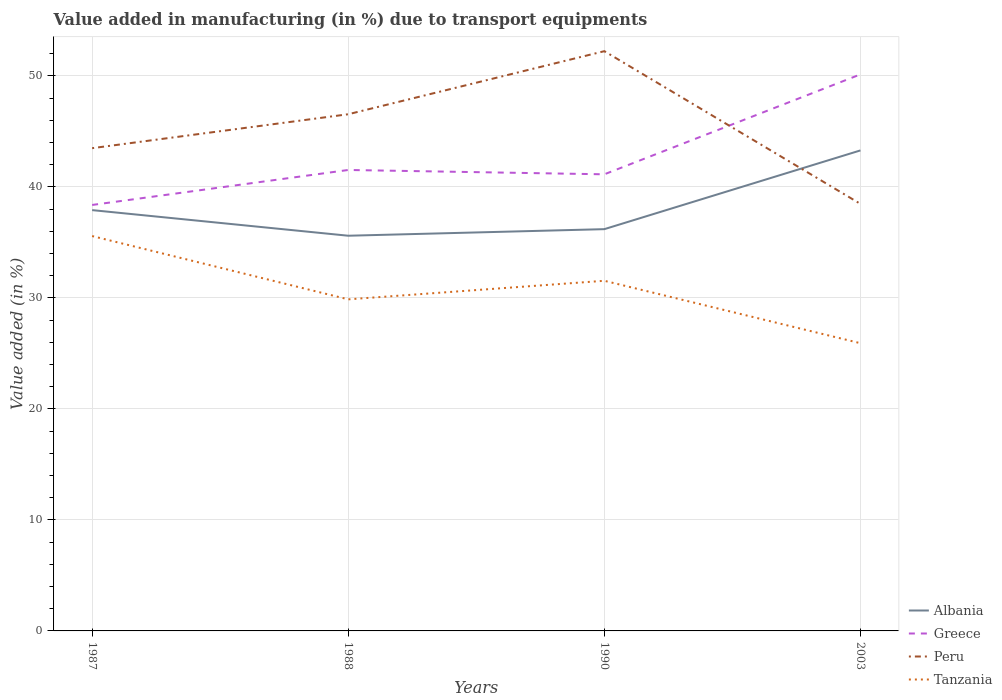Does the line corresponding to Greece intersect with the line corresponding to Albania?
Your answer should be compact. No. Across all years, what is the maximum percentage of value added in manufacturing due to transport equipments in Greece?
Ensure brevity in your answer.  38.37. What is the total percentage of value added in manufacturing due to transport equipments in Greece in the graph?
Give a very brief answer. -9. What is the difference between the highest and the second highest percentage of value added in manufacturing due to transport equipments in Peru?
Offer a terse response. 13.76. How many years are there in the graph?
Your answer should be very brief. 4. How many legend labels are there?
Keep it short and to the point. 4. What is the title of the graph?
Offer a very short reply. Value added in manufacturing (in %) due to transport equipments. Does "Afghanistan" appear as one of the legend labels in the graph?
Make the answer very short. No. What is the label or title of the X-axis?
Your answer should be compact. Years. What is the label or title of the Y-axis?
Your response must be concise. Value added (in %). What is the Value added (in %) of Albania in 1987?
Your response must be concise. 37.91. What is the Value added (in %) of Greece in 1987?
Provide a succinct answer. 38.37. What is the Value added (in %) of Peru in 1987?
Provide a succinct answer. 43.49. What is the Value added (in %) of Tanzania in 1987?
Make the answer very short. 35.57. What is the Value added (in %) in Albania in 1988?
Provide a short and direct response. 35.6. What is the Value added (in %) of Greece in 1988?
Your response must be concise. 41.52. What is the Value added (in %) in Peru in 1988?
Offer a terse response. 46.55. What is the Value added (in %) in Tanzania in 1988?
Your answer should be very brief. 29.87. What is the Value added (in %) in Albania in 1990?
Offer a terse response. 36.19. What is the Value added (in %) of Greece in 1990?
Ensure brevity in your answer.  41.13. What is the Value added (in %) in Peru in 1990?
Provide a succinct answer. 52.23. What is the Value added (in %) in Tanzania in 1990?
Offer a terse response. 31.54. What is the Value added (in %) of Albania in 2003?
Your response must be concise. 43.29. What is the Value added (in %) in Greece in 2003?
Make the answer very short. 50.14. What is the Value added (in %) in Peru in 2003?
Provide a short and direct response. 38.47. What is the Value added (in %) of Tanzania in 2003?
Keep it short and to the point. 25.92. Across all years, what is the maximum Value added (in %) in Albania?
Your answer should be very brief. 43.29. Across all years, what is the maximum Value added (in %) in Greece?
Provide a short and direct response. 50.14. Across all years, what is the maximum Value added (in %) of Peru?
Provide a short and direct response. 52.23. Across all years, what is the maximum Value added (in %) in Tanzania?
Ensure brevity in your answer.  35.57. Across all years, what is the minimum Value added (in %) in Albania?
Offer a terse response. 35.6. Across all years, what is the minimum Value added (in %) in Greece?
Provide a succinct answer. 38.37. Across all years, what is the minimum Value added (in %) of Peru?
Make the answer very short. 38.47. Across all years, what is the minimum Value added (in %) in Tanzania?
Offer a very short reply. 25.92. What is the total Value added (in %) in Albania in the graph?
Give a very brief answer. 152.99. What is the total Value added (in %) in Greece in the graph?
Keep it short and to the point. 171.17. What is the total Value added (in %) in Peru in the graph?
Give a very brief answer. 180.73. What is the total Value added (in %) of Tanzania in the graph?
Keep it short and to the point. 122.9. What is the difference between the Value added (in %) of Albania in 1987 and that in 1988?
Provide a short and direct response. 2.31. What is the difference between the Value added (in %) of Greece in 1987 and that in 1988?
Provide a short and direct response. -3.15. What is the difference between the Value added (in %) in Peru in 1987 and that in 1988?
Your answer should be very brief. -3.06. What is the difference between the Value added (in %) in Tanzania in 1987 and that in 1988?
Provide a short and direct response. 5.7. What is the difference between the Value added (in %) of Albania in 1987 and that in 1990?
Ensure brevity in your answer.  1.71. What is the difference between the Value added (in %) in Greece in 1987 and that in 1990?
Offer a terse response. -2.76. What is the difference between the Value added (in %) of Peru in 1987 and that in 1990?
Provide a succinct answer. -8.74. What is the difference between the Value added (in %) in Tanzania in 1987 and that in 1990?
Provide a succinct answer. 4.03. What is the difference between the Value added (in %) of Albania in 1987 and that in 2003?
Your answer should be very brief. -5.38. What is the difference between the Value added (in %) of Greece in 1987 and that in 2003?
Provide a short and direct response. -11.76. What is the difference between the Value added (in %) in Peru in 1987 and that in 2003?
Give a very brief answer. 5.02. What is the difference between the Value added (in %) of Tanzania in 1987 and that in 2003?
Make the answer very short. 9.65. What is the difference between the Value added (in %) in Albania in 1988 and that in 1990?
Your answer should be compact. -0.59. What is the difference between the Value added (in %) in Greece in 1988 and that in 1990?
Keep it short and to the point. 0.39. What is the difference between the Value added (in %) of Peru in 1988 and that in 1990?
Offer a very short reply. -5.68. What is the difference between the Value added (in %) of Tanzania in 1988 and that in 1990?
Offer a terse response. -1.67. What is the difference between the Value added (in %) in Albania in 1988 and that in 2003?
Offer a terse response. -7.69. What is the difference between the Value added (in %) in Greece in 1988 and that in 2003?
Offer a very short reply. -8.61. What is the difference between the Value added (in %) of Peru in 1988 and that in 2003?
Offer a terse response. 8.08. What is the difference between the Value added (in %) in Tanzania in 1988 and that in 2003?
Provide a succinct answer. 3.95. What is the difference between the Value added (in %) in Albania in 1990 and that in 2003?
Provide a succinct answer. -7.09. What is the difference between the Value added (in %) of Greece in 1990 and that in 2003?
Offer a terse response. -9. What is the difference between the Value added (in %) of Peru in 1990 and that in 2003?
Your response must be concise. 13.76. What is the difference between the Value added (in %) of Tanzania in 1990 and that in 2003?
Offer a very short reply. 5.62. What is the difference between the Value added (in %) of Albania in 1987 and the Value added (in %) of Greece in 1988?
Your answer should be very brief. -3.62. What is the difference between the Value added (in %) of Albania in 1987 and the Value added (in %) of Peru in 1988?
Offer a terse response. -8.64. What is the difference between the Value added (in %) of Albania in 1987 and the Value added (in %) of Tanzania in 1988?
Your answer should be compact. 8.04. What is the difference between the Value added (in %) in Greece in 1987 and the Value added (in %) in Peru in 1988?
Ensure brevity in your answer.  -8.17. What is the difference between the Value added (in %) in Greece in 1987 and the Value added (in %) in Tanzania in 1988?
Keep it short and to the point. 8.5. What is the difference between the Value added (in %) in Peru in 1987 and the Value added (in %) in Tanzania in 1988?
Ensure brevity in your answer.  13.62. What is the difference between the Value added (in %) of Albania in 1987 and the Value added (in %) of Greece in 1990?
Give a very brief answer. -3.23. What is the difference between the Value added (in %) of Albania in 1987 and the Value added (in %) of Peru in 1990?
Provide a succinct answer. -14.32. What is the difference between the Value added (in %) in Albania in 1987 and the Value added (in %) in Tanzania in 1990?
Your answer should be compact. 6.37. What is the difference between the Value added (in %) of Greece in 1987 and the Value added (in %) of Peru in 1990?
Provide a succinct answer. -13.85. What is the difference between the Value added (in %) of Greece in 1987 and the Value added (in %) of Tanzania in 1990?
Offer a very short reply. 6.83. What is the difference between the Value added (in %) in Peru in 1987 and the Value added (in %) in Tanzania in 1990?
Make the answer very short. 11.95. What is the difference between the Value added (in %) of Albania in 1987 and the Value added (in %) of Greece in 2003?
Keep it short and to the point. -12.23. What is the difference between the Value added (in %) of Albania in 1987 and the Value added (in %) of Peru in 2003?
Make the answer very short. -0.56. What is the difference between the Value added (in %) of Albania in 1987 and the Value added (in %) of Tanzania in 2003?
Offer a terse response. 11.99. What is the difference between the Value added (in %) in Greece in 1987 and the Value added (in %) in Peru in 2003?
Make the answer very short. -0.1. What is the difference between the Value added (in %) in Greece in 1987 and the Value added (in %) in Tanzania in 2003?
Your answer should be compact. 12.46. What is the difference between the Value added (in %) in Peru in 1987 and the Value added (in %) in Tanzania in 2003?
Provide a short and direct response. 17.57. What is the difference between the Value added (in %) in Albania in 1988 and the Value added (in %) in Greece in 1990?
Offer a very short reply. -5.53. What is the difference between the Value added (in %) in Albania in 1988 and the Value added (in %) in Peru in 1990?
Your answer should be very brief. -16.63. What is the difference between the Value added (in %) in Albania in 1988 and the Value added (in %) in Tanzania in 1990?
Keep it short and to the point. 4.06. What is the difference between the Value added (in %) in Greece in 1988 and the Value added (in %) in Peru in 1990?
Provide a succinct answer. -10.7. What is the difference between the Value added (in %) in Greece in 1988 and the Value added (in %) in Tanzania in 1990?
Keep it short and to the point. 9.98. What is the difference between the Value added (in %) in Peru in 1988 and the Value added (in %) in Tanzania in 1990?
Make the answer very short. 15. What is the difference between the Value added (in %) in Albania in 1988 and the Value added (in %) in Greece in 2003?
Your answer should be compact. -14.54. What is the difference between the Value added (in %) in Albania in 1988 and the Value added (in %) in Peru in 2003?
Keep it short and to the point. -2.87. What is the difference between the Value added (in %) in Albania in 1988 and the Value added (in %) in Tanzania in 2003?
Give a very brief answer. 9.68. What is the difference between the Value added (in %) of Greece in 1988 and the Value added (in %) of Peru in 2003?
Your answer should be compact. 3.06. What is the difference between the Value added (in %) of Greece in 1988 and the Value added (in %) of Tanzania in 2003?
Offer a very short reply. 15.61. What is the difference between the Value added (in %) of Peru in 1988 and the Value added (in %) of Tanzania in 2003?
Your answer should be very brief. 20.63. What is the difference between the Value added (in %) in Albania in 1990 and the Value added (in %) in Greece in 2003?
Offer a very short reply. -13.94. What is the difference between the Value added (in %) in Albania in 1990 and the Value added (in %) in Peru in 2003?
Keep it short and to the point. -2.27. What is the difference between the Value added (in %) of Albania in 1990 and the Value added (in %) of Tanzania in 2003?
Provide a succinct answer. 10.28. What is the difference between the Value added (in %) in Greece in 1990 and the Value added (in %) in Peru in 2003?
Keep it short and to the point. 2.67. What is the difference between the Value added (in %) in Greece in 1990 and the Value added (in %) in Tanzania in 2003?
Your answer should be compact. 15.22. What is the difference between the Value added (in %) in Peru in 1990 and the Value added (in %) in Tanzania in 2003?
Your answer should be very brief. 26.31. What is the average Value added (in %) in Albania per year?
Keep it short and to the point. 38.25. What is the average Value added (in %) of Greece per year?
Make the answer very short. 42.79. What is the average Value added (in %) in Peru per year?
Provide a short and direct response. 45.18. What is the average Value added (in %) of Tanzania per year?
Ensure brevity in your answer.  30.73. In the year 1987, what is the difference between the Value added (in %) in Albania and Value added (in %) in Greece?
Offer a very short reply. -0.46. In the year 1987, what is the difference between the Value added (in %) of Albania and Value added (in %) of Peru?
Ensure brevity in your answer.  -5.58. In the year 1987, what is the difference between the Value added (in %) of Albania and Value added (in %) of Tanzania?
Your response must be concise. 2.34. In the year 1987, what is the difference between the Value added (in %) in Greece and Value added (in %) in Peru?
Provide a short and direct response. -5.11. In the year 1987, what is the difference between the Value added (in %) of Greece and Value added (in %) of Tanzania?
Provide a succinct answer. 2.8. In the year 1987, what is the difference between the Value added (in %) of Peru and Value added (in %) of Tanzania?
Provide a short and direct response. 7.92. In the year 1988, what is the difference between the Value added (in %) in Albania and Value added (in %) in Greece?
Offer a very short reply. -5.92. In the year 1988, what is the difference between the Value added (in %) in Albania and Value added (in %) in Peru?
Keep it short and to the point. -10.94. In the year 1988, what is the difference between the Value added (in %) of Albania and Value added (in %) of Tanzania?
Make the answer very short. 5.73. In the year 1988, what is the difference between the Value added (in %) of Greece and Value added (in %) of Peru?
Provide a short and direct response. -5.02. In the year 1988, what is the difference between the Value added (in %) of Greece and Value added (in %) of Tanzania?
Provide a succinct answer. 11.65. In the year 1988, what is the difference between the Value added (in %) of Peru and Value added (in %) of Tanzania?
Offer a very short reply. 16.68. In the year 1990, what is the difference between the Value added (in %) in Albania and Value added (in %) in Greece?
Your answer should be compact. -4.94. In the year 1990, what is the difference between the Value added (in %) in Albania and Value added (in %) in Peru?
Provide a short and direct response. -16.03. In the year 1990, what is the difference between the Value added (in %) of Albania and Value added (in %) of Tanzania?
Keep it short and to the point. 4.65. In the year 1990, what is the difference between the Value added (in %) of Greece and Value added (in %) of Peru?
Provide a succinct answer. -11.09. In the year 1990, what is the difference between the Value added (in %) in Greece and Value added (in %) in Tanzania?
Your answer should be very brief. 9.59. In the year 1990, what is the difference between the Value added (in %) of Peru and Value added (in %) of Tanzania?
Your response must be concise. 20.68. In the year 2003, what is the difference between the Value added (in %) in Albania and Value added (in %) in Greece?
Offer a very short reply. -6.85. In the year 2003, what is the difference between the Value added (in %) in Albania and Value added (in %) in Peru?
Provide a short and direct response. 4.82. In the year 2003, what is the difference between the Value added (in %) in Albania and Value added (in %) in Tanzania?
Give a very brief answer. 17.37. In the year 2003, what is the difference between the Value added (in %) in Greece and Value added (in %) in Peru?
Make the answer very short. 11.67. In the year 2003, what is the difference between the Value added (in %) in Greece and Value added (in %) in Tanzania?
Offer a terse response. 24.22. In the year 2003, what is the difference between the Value added (in %) in Peru and Value added (in %) in Tanzania?
Your response must be concise. 12.55. What is the ratio of the Value added (in %) of Albania in 1987 to that in 1988?
Provide a short and direct response. 1.06. What is the ratio of the Value added (in %) in Greece in 1987 to that in 1988?
Your response must be concise. 0.92. What is the ratio of the Value added (in %) of Peru in 1987 to that in 1988?
Your answer should be very brief. 0.93. What is the ratio of the Value added (in %) in Tanzania in 1987 to that in 1988?
Offer a terse response. 1.19. What is the ratio of the Value added (in %) in Albania in 1987 to that in 1990?
Your answer should be compact. 1.05. What is the ratio of the Value added (in %) in Greece in 1987 to that in 1990?
Provide a short and direct response. 0.93. What is the ratio of the Value added (in %) in Peru in 1987 to that in 1990?
Offer a terse response. 0.83. What is the ratio of the Value added (in %) in Tanzania in 1987 to that in 1990?
Ensure brevity in your answer.  1.13. What is the ratio of the Value added (in %) of Albania in 1987 to that in 2003?
Ensure brevity in your answer.  0.88. What is the ratio of the Value added (in %) in Greece in 1987 to that in 2003?
Keep it short and to the point. 0.77. What is the ratio of the Value added (in %) in Peru in 1987 to that in 2003?
Offer a terse response. 1.13. What is the ratio of the Value added (in %) in Tanzania in 1987 to that in 2003?
Offer a very short reply. 1.37. What is the ratio of the Value added (in %) in Albania in 1988 to that in 1990?
Provide a succinct answer. 0.98. What is the ratio of the Value added (in %) in Greece in 1988 to that in 1990?
Your response must be concise. 1.01. What is the ratio of the Value added (in %) of Peru in 1988 to that in 1990?
Provide a short and direct response. 0.89. What is the ratio of the Value added (in %) of Tanzania in 1988 to that in 1990?
Offer a very short reply. 0.95. What is the ratio of the Value added (in %) in Albania in 1988 to that in 2003?
Offer a terse response. 0.82. What is the ratio of the Value added (in %) of Greece in 1988 to that in 2003?
Provide a short and direct response. 0.83. What is the ratio of the Value added (in %) in Peru in 1988 to that in 2003?
Offer a terse response. 1.21. What is the ratio of the Value added (in %) of Tanzania in 1988 to that in 2003?
Your response must be concise. 1.15. What is the ratio of the Value added (in %) in Albania in 1990 to that in 2003?
Offer a very short reply. 0.84. What is the ratio of the Value added (in %) in Greece in 1990 to that in 2003?
Keep it short and to the point. 0.82. What is the ratio of the Value added (in %) of Peru in 1990 to that in 2003?
Your response must be concise. 1.36. What is the ratio of the Value added (in %) of Tanzania in 1990 to that in 2003?
Offer a very short reply. 1.22. What is the difference between the highest and the second highest Value added (in %) in Albania?
Offer a terse response. 5.38. What is the difference between the highest and the second highest Value added (in %) of Greece?
Provide a succinct answer. 8.61. What is the difference between the highest and the second highest Value added (in %) of Peru?
Your answer should be very brief. 5.68. What is the difference between the highest and the second highest Value added (in %) of Tanzania?
Provide a succinct answer. 4.03. What is the difference between the highest and the lowest Value added (in %) in Albania?
Your answer should be very brief. 7.69. What is the difference between the highest and the lowest Value added (in %) of Greece?
Your answer should be compact. 11.76. What is the difference between the highest and the lowest Value added (in %) in Peru?
Ensure brevity in your answer.  13.76. What is the difference between the highest and the lowest Value added (in %) in Tanzania?
Your response must be concise. 9.65. 